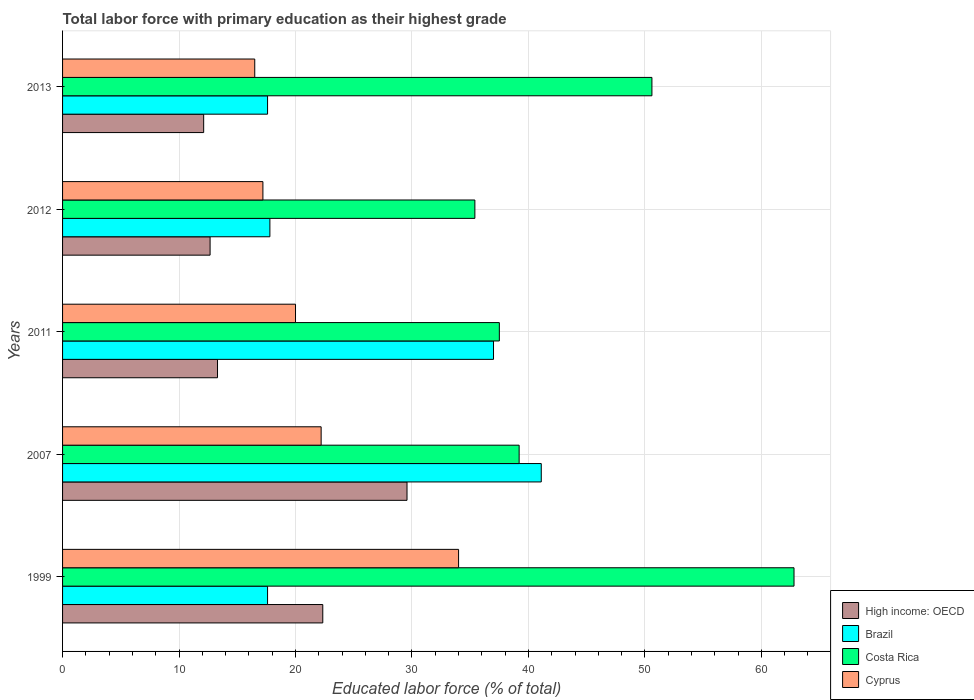How many different coloured bars are there?
Ensure brevity in your answer.  4. How many groups of bars are there?
Make the answer very short. 5. Are the number of bars on each tick of the Y-axis equal?
Your answer should be compact. Yes. How many bars are there on the 3rd tick from the top?
Offer a terse response. 4. How many bars are there on the 2nd tick from the bottom?
Offer a terse response. 4. What is the label of the 2nd group of bars from the top?
Keep it short and to the point. 2012. In how many cases, is the number of bars for a given year not equal to the number of legend labels?
Your answer should be compact. 0. What is the percentage of total labor force with primary education in Brazil in 2007?
Offer a very short reply. 41.1. Across all years, what is the maximum percentage of total labor force with primary education in Brazil?
Provide a succinct answer. 41.1. In which year was the percentage of total labor force with primary education in High income: OECD minimum?
Keep it short and to the point. 2013. What is the total percentage of total labor force with primary education in Costa Rica in the graph?
Ensure brevity in your answer.  225.5. What is the difference between the percentage of total labor force with primary education in Costa Rica in 2007 and that in 2011?
Provide a short and direct response. 1.7. What is the difference between the percentage of total labor force with primary education in Cyprus in 2013 and the percentage of total labor force with primary education in Costa Rica in 2007?
Ensure brevity in your answer.  -22.7. What is the average percentage of total labor force with primary education in High income: OECD per year?
Your response must be concise. 18. In the year 2012, what is the difference between the percentage of total labor force with primary education in Costa Rica and percentage of total labor force with primary education in Cyprus?
Ensure brevity in your answer.  18.2. What is the ratio of the percentage of total labor force with primary education in Cyprus in 1999 to that in 2013?
Offer a terse response. 2.06. Is the difference between the percentage of total labor force with primary education in Costa Rica in 1999 and 2012 greater than the difference between the percentage of total labor force with primary education in Cyprus in 1999 and 2012?
Your answer should be very brief. Yes. What is the difference between the highest and the second highest percentage of total labor force with primary education in Cyprus?
Your response must be concise. 11.8. What is the difference between the highest and the lowest percentage of total labor force with primary education in High income: OECD?
Your response must be concise. 17.46. What does the 4th bar from the top in 2012 represents?
Your answer should be very brief. High income: OECD. What does the 1st bar from the bottom in 2011 represents?
Offer a very short reply. High income: OECD. How many bars are there?
Your answer should be compact. 20. How many years are there in the graph?
Your answer should be very brief. 5. Are the values on the major ticks of X-axis written in scientific E-notation?
Make the answer very short. No. Does the graph contain any zero values?
Your response must be concise. No. Does the graph contain grids?
Keep it short and to the point. Yes. Where does the legend appear in the graph?
Keep it short and to the point. Bottom right. How many legend labels are there?
Keep it short and to the point. 4. How are the legend labels stacked?
Ensure brevity in your answer.  Vertical. What is the title of the graph?
Offer a terse response. Total labor force with primary education as their highest grade. Does "Barbados" appear as one of the legend labels in the graph?
Your answer should be compact. No. What is the label or title of the X-axis?
Ensure brevity in your answer.  Educated labor force (% of total). What is the Educated labor force (% of total) in High income: OECD in 1999?
Make the answer very short. 22.34. What is the Educated labor force (% of total) in Brazil in 1999?
Provide a succinct answer. 17.6. What is the Educated labor force (% of total) in Costa Rica in 1999?
Your answer should be compact. 62.8. What is the Educated labor force (% of total) in Cyprus in 1999?
Provide a succinct answer. 34. What is the Educated labor force (% of total) in High income: OECD in 2007?
Offer a very short reply. 29.57. What is the Educated labor force (% of total) in Brazil in 2007?
Your response must be concise. 41.1. What is the Educated labor force (% of total) of Costa Rica in 2007?
Ensure brevity in your answer.  39.2. What is the Educated labor force (% of total) in Cyprus in 2007?
Provide a short and direct response. 22.2. What is the Educated labor force (% of total) of High income: OECD in 2011?
Keep it short and to the point. 13.3. What is the Educated labor force (% of total) in Costa Rica in 2011?
Offer a terse response. 37.5. What is the Educated labor force (% of total) in High income: OECD in 2012?
Your answer should be very brief. 12.67. What is the Educated labor force (% of total) of Brazil in 2012?
Offer a very short reply. 17.8. What is the Educated labor force (% of total) of Costa Rica in 2012?
Ensure brevity in your answer.  35.4. What is the Educated labor force (% of total) in Cyprus in 2012?
Your answer should be compact. 17.2. What is the Educated labor force (% of total) of High income: OECD in 2013?
Make the answer very short. 12.11. What is the Educated labor force (% of total) of Brazil in 2013?
Offer a very short reply. 17.6. What is the Educated labor force (% of total) in Costa Rica in 2013?
Offer a very short reply. 50.6. What is the Educated labor force (% of total) in Cyprus in 2013?
Provide a succinct answer. 16.5. Across all years, what is the maximum Educated labor force (% of total) in High income: OECD?
Make the answer very short. 29.57. Across all years, what is the maximum Educated labor force (% of total) of Brazil?
Ensure brevity in your answer.  41.1. Across all years, what is the maximum Educated labor force (% of total) of Costa Rica?
Make the answer very short. 62.8. Across all years, what is the maximum Educated labor force (% of total) in Cyprus?
Offer a terse response. 34. Across all years, what is the minimum Educated labor force (% of total) in High income: OECD?
Your response must be concise. 12.11. Across all years, what is the minimum Educated labor force (% of total) in Brazil?
Ensure brevity in your answer.  17.6. Across all years, what is the minimum Educated labor force (% of total) of Costa Rica?
Your answer should be very brief. 35.4. What is the total Educated labor force (% of total) of High income: OECD in the graph?
Provide a succinct answer. 90. What is the total Educated labor force (% of total) of Brazil in the graph?
Your answer should be very brief. 131.1. What is the total Educated labor force (% of total) of Costa Rica in the graph?
Provide a short and direct response. 225.5. What is the total Educated labor force (% of total) of Cyprus in the graph?
Give a very brief answer. 109.9. What is the difference between the Educated labor force (% of total) of High income: OECD in 1999 and that in 2007?
Give a very brief answer. -7.23. What is the difference between the Educated labor force (% of total) in Brazil in 1999 and that in 2007?
Provide a short and direct response. -23.5. What is the difference between the Educated labor force (% of total) in Costa Rica in 1999 and that in 2007?
Your response must be concise. 23.6. What is the difference between the Educated labor force (% of total) of High income: OECD in 1999 and that in 2011?
Your response must be concise. 9.04. What is the difference between the Educated labor force (% of total) of Brazil in 1999 and that in 2011?
Offer a terse response. -19.4. What is the difference between the Educated labor force (% of total) of Costa Rica in 1999 and that in 2011?
Provide a succinct answer. 25.3. What is the difference between the Educated labor force (% of total) in High income: OECD in 1999 and that in 2012?
Your response must be concise. 9.68. What is the difference between the Educated labor force (% of total) of Costa Rica in 1999 and that in 2012?
Offer a terse response. 27.4. What is the difference between the Educated labor force (% of total) in High income: OECD in 1999 and that in 2013?
Give a very brief answer. 10.23. What is the difference between the Educated labor force (% of total) of High income: OECD in 2007 and that in 2011?
Provide a short and direct response. 16.27. What is the difference between the Educated labor force (% of total) of Costa Rica in 2007 and that in 2011?
Ensure brevity in your answer.  1.7. What is the difference between the Educated labor force (% of total) in Cyprus in 2007 and that in 2011?
Offer a very short reply. 2.2. What is the difference between the Educated labor force (% of total) of High income: OECD in 2007 and that in 2012?
Keep it short and to the point. 16.91. What is the difference between the Educated labor force (% of total) in Brazil in 2007 and that in 2012?
Offer a very short reply. 23.3. What is the difference between the Educated labor force (% of total) of Costa Rica in 2007 and that in 2012?
Offer a very short reply. 3.8. What is the difference between the Educated labor force (% of total) of High income: OECD in 2007 and that in 2013?
Offer a terse response. 17.46. What is the difference between the Educated labor force (% of total) in Cyprus in 2007 and that in 2013?
Give a very brief answer. 5.7. What is the difference between the Educated labor force (% of total) of High income: OECD in 2011 and that in 2012?
Provide a short and direct response. 0.64. What is the difference between the Educated labor force (% of total) of Brazil in 2011 and that in 2012?
Make the answer very short. 19.2. What is the difference between the Educated labor force (% of total) in Costa Rica in 2011 and that in 2012?
Give a very brief answer. 2.1. What is the difference between the Educated labor force (% of total) in High income: OECD in 2011 and that in 2013?
Your answer should be compact. 1.19. What is the difference between the Educated labor force (% of total) of Costa Rica in 2011 and that in 2013?
Your answer should be very brief. -13.1. What is the difference between the Educated labor force (% of total) in High income: OECD in 2012 and that in 2013?
Provide a short and direct response. 0.55. What is the difference between the Educated labor force (% of total) of Costa Rica in 2012 and that in 2013?
Give a very brief answer. -15.2. What is the difference between the Educated labor force (% of total) in High income: OECD in 1999 and the Educated labor force (% of total) in Brazil in 2007?
Provide a short and direct response. -18.76. What is the difference between the Educated labor force (% of total) in High income: OECD in 1999 and the Educated labor force (% of total) in Costa Rica in 2007?
Offer a terse response. -16.86. What is the difference between the Educated labor force (% of total) in High income: OECD in 1999 and the Educated labor force (% of total) in Cyprus in 2007?
Offer a very short reply. 0.14. What is the difference between the Educated labor force (% of total) of Brazil in 1999 and the Educated labor force (% of total) of Costa Rica in 2007?
Ensure brevity in your answer.  -21.6. What is the difference between the Educated labor force (% of total) in Costa Rica in 1999 and the Educated labor force (% of total) in Cyprus in 2007?
Your answer should be very brief. 40.6. What is the difference between the Educated labor force (% of total) in High income: OECD in 1999 and the Educated labor force (% of total) in Brazil in 2011?
Offer a terse response. -14.66. What is the difference between the Educated labor force (% of total) in High income: OECD in 1999 and the Educated labor force (% of total) in Costa Rica in 2011?
Provide a succinct answer. -15.16. What is the difference between the Educated labor force (% of total) in High income: OECD in 1999 and the Educated labor force (% of total) in Cyprus in 2011?
Ensure brevity in your answer.  2.34. What is the difference between the Educated labor force (% of total) in Brazil in 1999 and the Educated labor force (% of total) in Costa Rica in 2011?
Provide a succinct answer. -19.9. What is the difference between the Educated labor force (% of total) of Brazil in 1999 and the Educated labor force (% of total) of Cyprus in 2011?
Keep it short and to the point. -2.4. What is the difference between the Educated labor force (% of total) of Costa Rica in 1999 and the Educated labor force (% of total) of Cyprus in 2011?
Your answer should be compact. 42.8. What is the difference between the Educated labor force (% of total) in High income: OECD in 1999 and the Educated labor force (% of total) in Brazil in 2012?
Provide a succinct answer. 4.54. What is the difference between the Educated labor force (% of total) of High income: OECD in 1999 and the Educated labor force (% of total) of Costa Rica in 2012?
Your answer should be very brief. -13.06. What is the difference between the Educated labor force (% of total) of High income: OECD in 1999 and the Educated labor force (% of total) of Cyprus in 2012?
Your answer should be very brief. 5.14. What is the difference between the Educated labor force (% of total) of Brazil in 1999 and the Educated labor force (% of total) of Costa Rica in 2012?
Ensure brevity in your answer.  -17.8. What is the difference between the Educated labor force (% of total) of Costa Rica in 1999 and the Educated labor force (% of total) of Cyprus in 2012?
Provide a short and direct response. 45.6. What is the difference between the Educated labor force (% of total) of High income: OECD in 1999 and the Educated labor force (% of total) of Brazil in 2013?
Offer a terse response. 4.74. What is the difference between the Educated labor force (% of total) of High income: OECD in 1999 and the Educated labor force (% of total) of Costa Rica in 2013?
Offer a very short reply. -28.26. What is the difference between the Educated labor force (% of total) in High income: OECD in 1999 and the Educated labor force (% of total) in Cyprus in 2013?
Offer a terse response. 5.84. What is the difference between the Educated labor force (% of total) in Brazil in 1999 and the Educated labor force (% of total) in Costa Rica in 2013?
Keep it short and to the point. -33. What is the difference between the Educated labor force (% of total) in Costa Rica in 1999 and the Educated labor force (% of total) in Cyprus in 2013?
Your answer should be very brief. 46.3. What is the difference between the Educated labor force (% of total) of High income: OECD in 2007 and the Educated labor force (% of total) of Brazil in 2011?
Make the answer very short. -7.43. What is the difference between the Educated labor force (% of total) in High income: OECD in 2007 and the Educated labor force (% of total) in Costa Rica in 2011?
Make the answer very short. -7.93. What is the difference between the Educated labor force (% of total) of High income: OECD in 2007 and the Educated labor force (% of total) of Cyprus in 2011?
Keep it short and to the point. 9.57. What is the difference between the Educated labor force (% of total) in Brazil in 2007 and the Educated labor force (% of total) in Cyprus in 2011?
Keep it short and to the point. 21.1. What is the difference between the Educated labor force (% of total) of Costa Rica in 2007 and the Educated labor force (% of total) of Cyprus in 2011?
Your answer should be compact. 19.2. What is the difference between the Educated labor force (% of total) in High income: OECD in 2007 and the Educated labor force (% of total) in Brazil in 2012?
Provide a short and direct response. 11.77. What is the difference between the Educated labor force (% of total) of High income: OECD in 2007 and the Educated labor force (% of total) of Costa Rica in 2012?
Offer a terse response. -5.83. What is the difference between the Educated labor force (% of total) in High income: OECD in 2007 and the Educated labor force (% of total) in Cyprus in 2012?
Keep it short and to the point. 12.37. What is the difference between the Educated labor force (% of total) in Brazil in 2007 and the Educated labor force (% of total) in Cyprus in 2012?
Offer a terse response. 23.9. What is the difference between the Educated labor force (% of total) of High income: OECD in 2007 and the Educated labor force (% of total) of Brazil in 2013?
Ensure brevity in your answer.  11.97. What is the difference between the Educated labor force (% of total) in High income: OECD in 2007 and the Educated labor force (% of total) in Costa Rica in 2013?
Make the answer very short. -21.03. What is the difference between the Educated labor force (% of total) of High income: OECD in 2007 and the Educated labor force (% of total) of Cyprus in 2013?
Provide a succinct answer. 13.07. What is the difference between the Educated labor force (% of total) of Brazil in 2007 and the Educated labor force (% of total) of Costa Rica in 2013?
Your response must be concise. -9.5. What is the difference between the Educated labor force (% of total) of Brazil in 2007 and the Educated labor force (% of total) of Cyprus in 2013?
Provide a succinct answer. 24.6. What is the difference between the Educated labor force (% of total) in Costa Rica in 2007 and the Educated labor force (% of total) in Cyprus in 2013?
Your answer should be very brief. 22.7. What is the difference between the Educated labor force (% of total) of High income: OECD in 2011 and the Educated labor force (% of total) of Brazil in 2012?
Offer a terse response. -4.5. What is the difference between the Educated labor force (% of total) of High income: OECD in 2011 and the Educated labor force (% of total) of Costa Rica in 2012?
Your response must be concise. -22.1. What is the difference between the Educated labor force (% of total) in High income: OECD in 2011 and the Educated labor force (% of total) in Cyprus in 2012?
Offer a very short reply. -3.9. What is the difference between the Educated labor force (% of total) in Brazil in 2011 and the Educated labor force (% of total) in Cyprus in 2012?
Your answer should be compact. 19.8. What is the difference between the Educated labor force (% of total) of Costa Rica in 2011 and the Educated labor force (% of total) of Cyprus in 2012?
Keep it short and to the point. 20.3. What is the difference between the Educated labor force (% of total) in High income: OECD in 2011 and the Educated labor force (% of total) in Brazil in 2013?
Provide a short and direct response. -4.3. What is the difference between the Educated labor force (% of total) of High income: OECD in 2011 and the Educated labor force (% of total) of Costa Rica in 2013?
Your response must be concise. -37.3. What is the difference between the Educated labor force (% of total) of High income: OECD in 2011 and the Educated labor force (% of total) of Cyprus in 2013?
Your answer should be compact. -3.2. What is the difference between the Educated labor force (% of total) of Brazil in 2011 and the Educated labor force (% of total) of Costa Rica in 2013?
Your response must be concise. -13.6. What is the difference between the Educated labor force (% of total) of Costa Rica in 2011 and the Educated labor force (% of total) of Cyprus in 2013?
Keep it short and to the point. 21. What is the difference between the Educated labor force (% of total) of High income: OECD in 2012 and the Educated labor force (% of total) of Brazil in 2013?
Offer a very short reply. -4.93. What is the difference between the Educated labor force (% of total) of High income: OECD in 2012 and the Educated labor force (% of total) of Costa Rica in 2013?
Keep it short and to the point. -37.93. What is the difference between the Educated labor force (% of total) of High income: OECD in 2012 and the Educated labor force (% of total) of Cyprus in 2013?
Your answer should be compact. -3.83. What is the difference between the Educated labor force (% of total) in Brazil in 2012 and the Educated labor force (% of total) in Costa Rica in 2013?
Provide a succinct answer. -32.8. What is the difference between the Educated labor force (% of total) in Brazil in 2012 and the Educated labor force (% of total) in Cyprus in 2013?
Give a very brief answer. 1.3. What is the average Educated labor force (% of total) of High income: OECD per year?
Your response must be concise. 18. What is the average Educated labor force (% of total) in Brazil per year?
Offer a very short reply. 26.22. What is the average Educated labor force (% of total) in Costa Rica per year?
Provide a succinct answer. 45.1. What is the average Educated labor force (% of total) of Cyprus per year?
Your answer should be compact. 21.98. In the year 1999, what is the difference between the Educated labor force (% of total) of High income: OECD and Educated labor force (% of total) of Brazil?
Make the answer very short. 4.74. In the year 1999, what is the difference between the Educated labor force (% of total) of High income: OECD and Educated labor force (% of total) of Costa Rica?
Offer a very short reply. -40.46. In the year 1999, what is the difference between the Educated labor force (% of total) of High income: OECD and Educated labor force (% of total) of Cyprus?
Give a very brief answer. -11.66. In the year 1999, what is the difference between the Educated labor force (% of total) in Brazil and Educated labor force (% of total) in Costa Rica?
Give a very brief answer. -45.2. In the year 1999, what is the difference between the Educated labor force (% of total) in Brazil and Educated labor force (% of total) in Cyprus?
Ensure brevity in your answer.  -16.4. In the year 1999, what is the difference between the Educated labor force (% of total) of Costa Rica and Educated labor force (% of total) of Cyprus?
Offer a terse response. 28.8. In the year 2007, what is the difference between the Educated labor force (% of total) in High income: OECD and Educated labor force (% of total) in Brazil?
Your response must be concise. -11.53. In the year 2007, what is the difference between the Educated labor force (% of total) in High income: OECD and Educated labor force (% of total) in Costa Rica?
Offer a very short reply. -9.63. In the year 2007, what is the difference between the Educated labor force (% of total) of High income: OECD and Educated labor force (% of total) of Cyprus?
Provide a short and direct response. 7.37. In the year 2007, what is the difference between the Educated labor force (% of total) of Brazil and Educated labor force (% of total) of Cyprus?
Your answer should be very brief. 18.9. In the year 2007, what is the difference between the Educated labor force (% of total) of Costa Rica and Educated labor force (% of total) of Cyprus?
Provide a short and direct response. 17. In the year 2011, what is the difference between the Educated labor force (% of total) in High income: OECD and Educated labor force (% of total) in Brazil?
Provide a succinct answer. -23.7. In the year 2011, what is the difference between the Educated labor force (% of total) in High income: OECD and Educated labor force (% of total) in Costa Rica?
Your answer should be very brief. -24.2. In the year 2011, what is the difference between the Educated labor force (% of total) in High income: OECD and Educated labor force (% of total) in Cyprus?
Your answer should be compact. -6.7. In the year 2012, what is the difference between the Educated labor force (% of total) of High income: OECD and Educated labor force (% of total) of Brazil?
Offer a very short reply. -5.13. In the year 2012, what is the difference between the Educated labor force (% of total) of High income: OECD and Educated labor force (% of total) of Costa Rica?
Keep it short and to the point. -22.73. In the year 2012, what is the difference between the Educated labor force (% of total) of High income: OECD and Educated labor force (% of total) of Cyprus?
Make the answer very short. -4.53. In the year 2012, what is the difference between the Educated labor force (% of total) in Brazil and Educated labor force (% of total) in Costa Rica?
Keep it short and to the point. -17.6. In the year 2012, what is the difference between the Educated labor force (% of total) of Brazil and Educated labor force (% of total) of Cyprus?
Your answer should be compact. 0.6. In the year 2012, what is the difference between the Educated labor force (% of total) in Costa Rica and Educated labor force (% of total) in Cyprus?
Your answer should be very brief. 18.2. In the year 2013, what is the difference between the Educated labor force (% of total) of High income: OECD and Educated labor force (% of total) of Brazil?
Provide a succinct answer. -5.49. In the year 2013, what is the difference between the Educated labor force (% of total) of High income: OECD and Educated labor force (% of total) of Costa Rica?
Provide a succinct answer. -38.49. In the year 2013, what is the difference between the Educated labor force (% of total) in High income: OECD and Educated labor force (% of total) in Cyprus?
Ensure brevity in your answer.  -4.39. In the year 2013, what is the difference between the Educated labor force (% of total) in Brazil and Educated labor force (% of total) in Costa Rica?
Offer a very short reply. -33. In the year 2013, what is the difference between the Educated labor force (% of total) in Costa Rica and Educated labor force (% of total) in Cyprus?
Ensure brevity in your answer.  34.1. What is the ratio of the Educated labor force (% of total) of High income: OECD in 1999 to that in 2007?
Your response must be concise. 0.76. What is the ratio of the Educated labor force (% of total) of Brazil in 1999 to that in 2007?
Your answer should be very brief. 0.43. What is the ratio of the Educated labor force (% of total) of Costa Rica in 1999 to that in 2007?
Keep it short and to the point. 1.6. What is the ratio of the Educated labor force (% of total) in Cyprus in 1999 to that in 2007?
Your answer should be very brief. 1.53. What is the ratio of the Educated labor force (% of total) in High income: OECD in 1999 to that in 2011?
Provide a succinct answer. 1.68. What is the ratio of the Educated labor force (% of total) in Brazil in 1999 to that in 2011?
Your response must be concise. 0.48. What is the ratio of the Educated labor force (% of total) of Costa Rica in 1999 to that in 2011?
Provide a short and direct response. 1.67. What is the ratio of the Educated labor force (% of total) of High income: OECD in 1999 to that in 2012?
Provide a short and direct response. 1.76. What is the ratio of the Educated labor force (% of total) of Brazil in 1999 to that in 2012?
Keep it short and to the point. 0.99. What is the ratio of the Educated labor force (% of total) in Costa Rica in 1999 to that in 2012?
Make the answer very short. 1.77. What is the ratio of the Educated labor force (% of total) in Cyprus in 1999 to that in 2012?
Offer a terse response. 1.98. What is the ratio of the Educated labor force (% of total) in High income: OECD in 1999 to that in 2013?
Offer a terse response. 1.84. What is the ratio of the Educated labor force (% of total) in Costa Rica in 1999 to that in 2013?
Your answer should be compact. 1.24. What is the ratio of the Educated labor force (% of total) in Cyprus in 1999 to that in 2013?
Give a very brief answer. 2.06. What is the ratio of the Educated labor force (% of total) of High income: OECD in 2007 to that in 2011?
Offer a terse response. 2.22. What is the ratio of the Educated labor force (% of total) in Brazil in 2007 to that in 2011?
Provide a short and direct response. 1.11. What is the ratio of the Educated labor force (% of total) in Costa Rica in 2007 to that in 2011?
Offer a very short reply. 1.05. What is the ratio of the Educated labor force (% of total) of Cyprus in 2007 to that in 2011?
Offer a terse response. 1.11. What is the ratio of the Educated labor force (% of total) of High income: OECD in 2007 to that in 2012?
Your answer should be very brief. 2.33. What is the ratio of the Educated labor force (% of total) of Brazil in 2007 to that in 2012?
Keep it short and to the point. 2.31. What is the ratio of the Educated labor force (% of total) in Costa Rica in 2007 to that in 2012?
Provide a succinct answer. 1.11. What is the ratio of the Educated labor force (% of total) of Cyprus in 2007 to that in 2012?
Give a very brief answer. 1.29. What is the ratio of the Educated labor force (% of total) of High income: OECD in 2007 to that in 2013?
Ensure brevity in your answer.  2.44. What is the ratio of the Educated labor force (% of total) in Brazil in 2007 to that in 2013?
Give a very brief answer. 2.34. What is the ratio of the Educated labor force (% of total) in Costa Rica in 2007 to that in 2013?
Provide a short and direct response. 0.77. What is the ratio of the Educated labor force (% of total) in Cyprus in 2007 to that in 2013?
Your answer should be very brief. 1.35. What is the ratio of the Educated labor force (% of total) of High income: OECD in 2011 to that in 2012?
Your answer should be very brief. 1.05. What is the ratio of the Educated labor force (% of total) in Brazil in 2011 to that in 2012?
Offer a terse response. 2.08. What is the ratio of the Educated labor force (% of total) of Costa Rica in 2011 to that in 2012?
Offer a very short reply. 1.06. What is the ratio of the Educated labor force (% of total) of Cyprus in 2011 to that in 2012?
Ensure brevity in your answer.  1.16. What is the ratio of the Educated labor force (% of total) in High income: OECD in 2011 to that in 2013?
Your answer should be compact. 1.1. What is the ratio of the Educated labor force (% of total) in Brazil in 2011 to that in 2013?
Your response must be concise. 2.1. What is the ratio of the Educated labor force (% of total) in Costa Rica in 2011 to that in 2013?
Offer a very short reply. 0.74. What is the ratio of the Educated labor force (% of total) of Cyprus in 2011 to that in 2013?
Your response must be concise. 1.21. What is the ratio of the Educated labor force (% of total) in High income: OECD in 2012 to that in 2013?
Offer a very short reply. 1.05. What is the ratio of the Educated labor force (% of total) of Brazil in 2012 to that in 2013?
Give a very brief answer. 1.01. What is the ratio of the Educated labor force (% of total) of Costa Rica in 2012 to that in 2013?
Your response must be concise. 0.7. What is the ratio of the Educated labor force (% of total) of Cyprus in 2012 to that in 2013?
Offer a terse response. 1.04. What is the difference between the highest and the second highest Educated labor force (% of total) of High income: OECD?
Give a very brief answer. 7.23. What is the difference between the highest and the lowest Educated labor force (% of total) in High income: OECD?
Ensure brevity in your answer.  17.46. What is the difference between the highest and the lowest Educated labor force (% of total) in Costa Rica?
Ensure brevity in your answer.  27.4. 